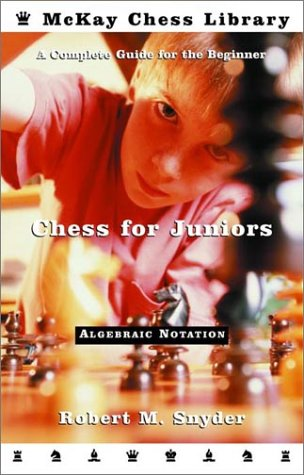What is the title of this book? The book's title is 'Chess for Juniors: A Complete Guide for the Beginner,' indicating its focus on instructing young chess enthusiasts. 